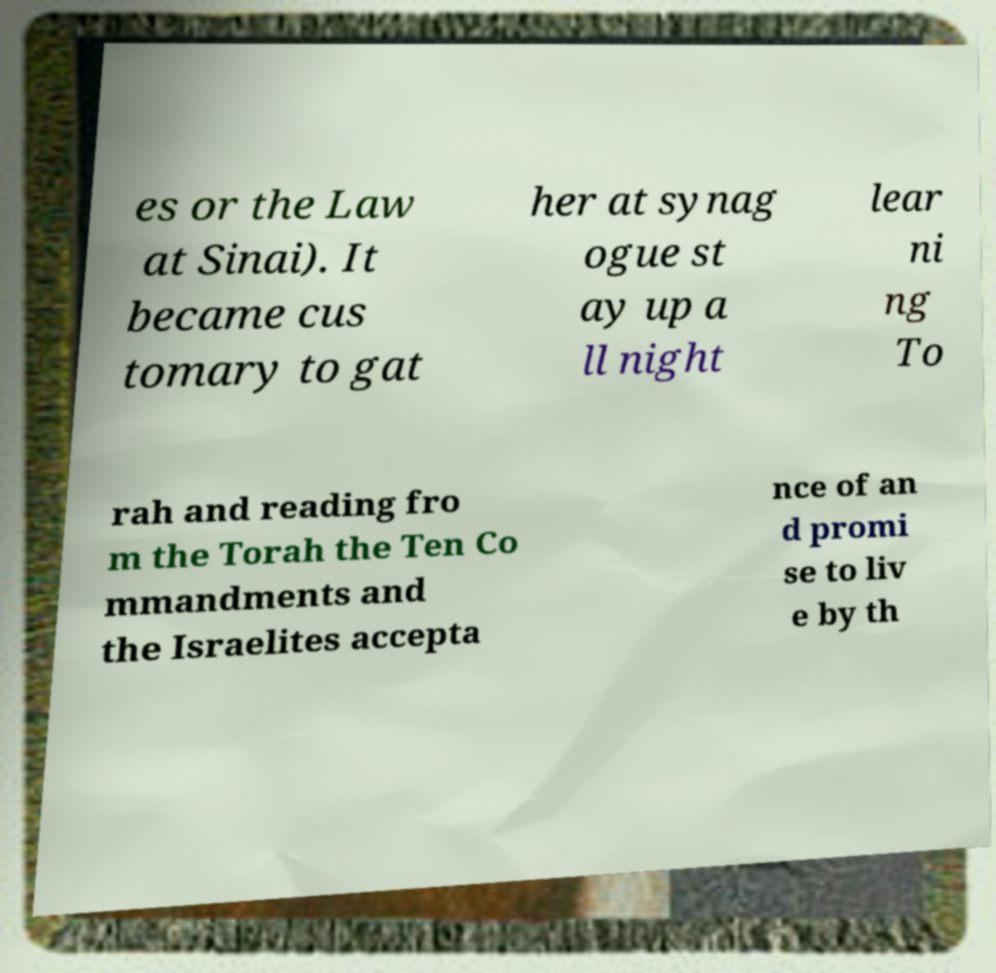Could you assist in decoding the text presented in this image and type it out clearly? es or the Law at Sinai). It became cus tomary to gat her at synag ogue st ay up a ll night lear ni ng To rah and reading fro m the Torah the Ten Co mmandments and the Israelites accepta nce of an d promi se to liv e by th 